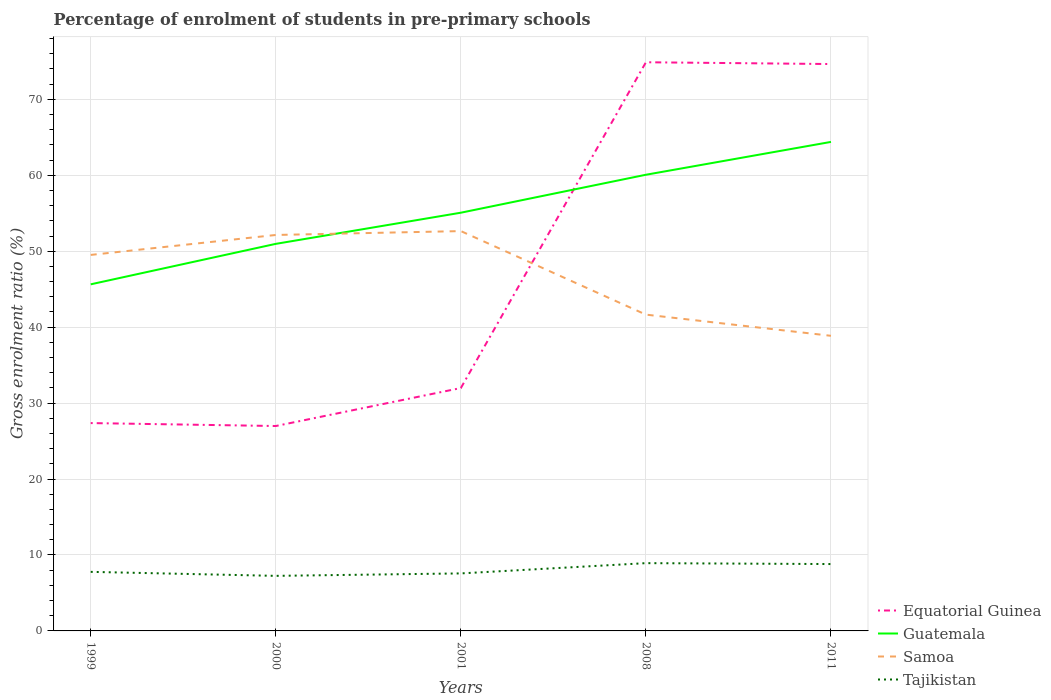How many different coloured lines are there?
Provide a short and direct response. 4. Is the number of lines equal to the number of legend labels?
Make the answer very short. Yes. Across all years, what is the maximum percentage of students enrolled in pre-primary schools in Guatemala?
Your answer should be very brief. 45.64. In which year was the percentage of students enrolled in pre-primary schools in Guatemala maximum?
Offer a very short reply. 1999. What is the total percentage of students enrolled in pre-primary schools in Guatemala in the graph?
Ensure brevity in your answer.  -4.32. What is the difference between the highest and the second highest percentage of students enrolled in pre-primary schools in Guatemala?
Give a very brief answer. 18.75. What is the difference between the highest and the lowest percentage of students enrolled in pre-primary schools in Guatemala?
Your answer should be compact. 2. How many lines are there?
Offer a very short reply. 4. How many years are there in the graph?
Your response must be concise. 5. What is the difference between two consecutive major ticks on the Y-axis?
Offer a very short reply. 10. Are the values on the major ticks of Y-axis written in scientific E-notation?
Your response must be concise. No. Where does the legend appear in the graph?
Provide a short and direct response. Bottom right. How are the legend labels stacked?
Your answer should be very brief. Vertical. What is the title of the graph?
Provide a short and direct response. Percentage of enrolment of students in pre-primary schools. Does "Thailand" appear as one of the legend labels in the graph?
Provide a succinct answer. No. What is the label or title of the Y-axis?
Your answer should be very brief. Gross enrolment ratio (%). What is the Gross enrolment ratio (%) of Equatorial Guinea in 1999?
Make the answer very short. 27.37. What is the Gross enrolment ratio (%) of Guatemala in 1999?
Your response must be concise. 45.64. What is the Gross enrolment ratio (%) of Samoa in 1999?
Your answer should be compact. 49.51. What is the Gross enrolment ratio (%) in Tajikistan in 1999?
Give a very brief answer. 7.78. What is the Gross enrolment ratio (%) in Equatorial Guinea in 2000?
Offer a very short reply. 26.98. What is the Gross enrolment ratio (%) in Guatemala in 2000?
Offer a terse response. 50.97. What is the Gross enrolment ratio (%) of Samoa in 2000?
Give a very brief answer. 52.14. What is the Gross enrolment ratio (%) in Tajikistan in 2000?
Keep it short and to the point. 7.25. What is the Gross enrolment ratio (%) in Equatorial Guinea in 2001?
Offer a very short reply. 31.98. What is the Gross enrolment ratio (%) in Guatemala in 2001?
Offer a very short reply. 55.07. What is the Gross enrolment ratio (%) of Samoa in 2001?
Your answer should be compact. 52.65. What is the Gross enrolment ratio (%) in Tajikistan in 2001?
Provide a succinct answer. 7.57. What is the Gross enrolment ratio (%) of Equatorial Guinea in 2008?
Provide a succinct answer. 74.88. What is the Gross enrolment ratio (%) of Guatemala in 2008?
Give a very brief answer. 60.07. What is the Gross enrolment ratio (%) in Samoa in 2008?
Give a very brief answer. 41.65. What is the Gross enrolment ratio (%) in Tajikistan in 2008?
Give a very brief answer. 8.92. What is the Gross enrolment ratio (%) of Equatorial Guinea in 2011?
Provide a short and direct response. 74.64. What is the Gross enrolment ratio (%) of Guatemala in 2011?
Offer a very short reply. 64.39. What is the Gross enrolment ratio (%) in Samoa in 2011?
Keep it short and to the point. 38.86. What is the Gross enrolment ratio (%) in Tajikistan in 2011?
Provide a succinct answer. 8.8. Across all years, what is the maximum Gross enrolment ratio (%) in Equatorial Guinea?
Offer a terse response. 74.88. Across all years, what is the maximum Gross enrolment ratio (%) of Guatemala?
Offer a very short reply. 64.39. Across all years, what is the maximum Gross enrolment ratio (%) in Samoa?
Keep it short and to the point. 52.65. Across all years, what is the maximum Gross enrolment ratio (%) in Tajikistan?
Your answer should be compact. 8.92. Across all years, what is the minimum Gross enrolment ratio (%) of Equatorial Guinea?
Offer a terse response. 26.98. Across all years, what is the minimum Gross enrolment ratio (%) of Guatemala?
Make the answer very short. 45.64. Across all years, what is the minimum Gross enrolment ratio (%) in Samoa?
Offer a terse response. 38.86. Across all years, what is the minimum Gross enrolment ratio (%) of Tajikistan?
Provide a succinct answer. 7.25. What is the total Gross enrolment ratio (%) of Equatorial Guinea in the graph?
Provide a short and direct response. 235.85. What is the total Gross enrolment ratio (%) of Guatemala in the graph?
Offer a terse response. 276.13. What is the total Gross enrolment ratio (%) of Samoa in the graph?
Offer a terse response. 234.8. What is the total Gross enrolment ratio (%) of Tajikistan in the graph?
Offer a terse response. 40.33. What is the difference between the Gross enrolment ratio (%) in Equatorial Guinea in 1999 and that in 2000?
Your answer should be very brief. 0.39. What is the difference between the Gross enrolment ratio (%) in Guatemala in 1999 and that in 2000?
Your answer should be very brief. -5.33. What is the difference between the Gross enrolment ratio (%) in Samoa in 1999 and that in 2000?
Keep it short and to the point. -2.63. What is the difference between the Gross enrolment ratio (%) in Tajikistan in 1999 and that in 2000?
Provide a succinct answer. 0.53. What is the difference between the Gross enrolment ratio (%) in Equatorial Guinea in 1999 and that in 2001?
Your answer should be compact. -4.61. What is the difference between the Gross enrolment ratio (%) in Guatemala in 1999 and that in 2001?
Make the answer very short. -9.43. What is the difference between the Gross enrolment ratio (%) of Samoa in 1999 and that in 2001?
Your answer should be very brief. -3.14. What is the difference between the Gross enrolment ratio (%) of Tajikistan in 1999 and that in 2001?
Ensure brevity in your answer.  0.2. What is the difference between the Gross enrolment ratio (%) in Equatorial Guinea in 1999 and that in 2008?
Make the answer very short. -47.51. What is the difference between the Gross enrolment ratio (%) in Guatemala in 1999 and that in 2008?
Provide a succinct answer. -14.43. What is the difference between the Gross enrolment ratio (%) of Samoa in 1999 and that in 2008?
Your answer should be very brief. 7.86. What is the difference between the Gross enrolment ratio (%) in Tajikistan in 1999 and that in 2008?
Make the answer very short. -1.15. What is the difference between the Gross enrolment ratio (%) of Equatorial Guinea in 1999 and that in 2011?
Keep it short and to the point. -47.27. What is the difference between the Gross enrolment ratio (%) of Guatemala in 1999 and that in 2011?
Give a very brief answer. -18.75. What is the difference between the Gross enrolment ratio (%) of Samoa in 1999 and that in 2011?
Make the answer very short. 10.65. What is the difference between the Gross enrolment ratio (%) in Tajikistan in 1999 and that in 2011?
Your answer should be very brief. -1.03. What is the difference between the Gross enrolment ratio (%) of Equatorial Guinea in 2000 and that in 2001?
Offer a terse response. -5. What is the difference between the Gross enrolment ratio (%) in Guatemala in 2000 and that in 2001?
Provide a short and direct response. -4.1. What is the difference between the Gross enrolment ratio (%) in Samoa in 2000 and that in 2001?
Offer a terse response. -0.51. What is the difference between the Gross enrolment ratio (%) in Tajikistan in 2000 and that in 2001?
Your answer should be compact. -0.32. What is the difference between the Gross enrolment ratio (%) in Equatorial Guinea in 2000 and that in 2008?
Offer a terse response. -47.9. What is the difference between the Gross enrolment ratio (%) in Guatemala in 2000 and that in 2008?
Provide a succinct answer. -9.1. What is the difference between the Gross enrolment ratio (%) of Samoa in 2000 and that in 2008?
Provide a short and direct response. 10.49. What is the difference between the Gross enrolment ratio (%) in Tajikistan in 2000 and that in 2008?
Offer a very short reply. -1.67. What is the difference between the Gross enrolment ratio (%) in Equatorial Guinea in 2000 and that in 2011?
Provide a short and direct response. -47.66. What is the difference between the Gross enrolment ratio (%) of Guatemala in 2000 and that in 2011?
Your answer should be very brief. -13.42. What is the difference between the Gross enrolment ratio (%) in Samoa in 2000 and that in 2011?
Offer a very short reply. 13.28. What is the difference between the Gross enrolment ratio (%) of Tajikistan in 2000 and that in 2011?
Provide a succinct answer. -1.55. What is the difference between the Gross enrolment ratio (%) of Equatorial Guinea in 2001 and that in 2008?
Make the answer very short. -42.9. What is the difference between the Gross enrolment ratio (%) of Guatemala in 2001 and that in 2008?
Your answer should be very brief. -5. What is the difference between the Gross enrolment ratio (%) of Samoa in 2001 and that in 2008?
Your answer should be very brief. 11. What is the difference between the Gross enrolment ratio (%) of Tajikistan in 2001 and that in 2008?
Offer a terse response. -1.35. What is the difference between the Gross enrolment ratio (%) of Equatorial Guinea in 2001 and that in 2011?
Offer a very short reply. -42.66. What is the difference between the Gross enrolment ratio (%) of Guatemala in 2001 and that in 2011?
Keep it short and to the point. -9.32. What is the difference between the Gross enrolment ratio (%) in Samoa in 2001 and that in 2011?
Your response must be concise. 13.79. What is the difference between the Gross enrolment ratio (%) of Tajikistan in 2001 and that in 2011?
Your response must be concise. -1.23. What is the difference between the Gross enrolment ratio (%) of Equatorial Guinea in 2008 and that in 2011?
Give a very brief answer. 0.24. What is the difference between the Gross enrolment ratio (%) in Guatemala in 2008 and that in 2011?
Give a very brief answer. -4.32. What is the difference between the Gross enrolment ratio (%) in Samoa in 2008 and that in 2011?
Your answer should be very brief. 2.79. What is the difference between the Gross enrolment ratio (%) of Tajikistan in 2008 and that in 2011?
Your answer should be compact. 0.12. What is the difference between the Gross enrolment ratio (%) of Equatorial Guinea in 1999 and the Gross enrolment ratio (%) of Guatemala in 2000?
Give a very brief answer. -23.6. What is the difference between the Gross enrolment ratio (%) in Equatorial Guinea in 1999 and the Gross enrolment ratio (%) in Samoa in 2000?
Offer a terse response. -24.77. What is the difference between the Gross enrolment ratio (%) of Equatorial Guinea in 1999 and the Gross enrolment ratio (%) of Tajikistan in 2000?
Your response must be concise. 20.12. What is the difference between the Gross enrolment ratio (%) in Guatemala in 1999 and the Gross enrolment ratio (%) in Samoa in 2000?
Your answer should be compact. -6.5. What is the difference between the Gross enrolment ratio (%) in Guatemala in 1999 and the Gross enrolment ratio (%) in Tajikistan in 2000?
Keep it short and to the point. 38.39. What is the difference between the Gross enrolment ratio (%) in Samoa in 1999 and the Gross enrolment ratio (%) in Tajikistan in 2000?
Provide a succinct answer. 42.26. What is the difference between the Gross enrolment ratio (%) in Equatorial Guinea in 1999 and the Gross enrolment ratio (%) in Guatemala in 2001?
Provide a short and direct response. -27.7. What is the difference between the Gross enrolment ratio (%) of Equatorial Guinea in 1999 and the Gross enrolment ratio (%) of Samoa in 2001?
Offer a terse response. -25.28. What is the difference between the Gross enrolment ratio (%) of Equatorial Guinea in 1999 and the Gross enrolment ratio (%) of Tajikistan in 2001?
Your answer should be very brief. 19.8. What is the difference between the Gross enrolment ratio (%) of Guatemala in 1999 and the Gross enrolment ratio (%) of Samoa in 2001?
Ensure brevity in your answer.  -7.01. What is the difference between the Gross enrolment ratio (%) in Guatemala in 1999 and the Gross enrolment ratio (%) in Tajikistan in 2001?
Give a very brief answer. 38.06. What is the difference between the Gross enrolment ratio (%) in Samoa in 1999 and the Gross enrolment ratio (%) in Tajikistan in 2001?
Provide a short and direct response. 41.94. What is the difference between the Gross enrolment ratio (%) of Equatorial Guinea in 1999 and the Gross enrolment ratio (%) of Guatemala in 2008?
Provide a succinct answer. -32.7. What is the difference between the Gross enrolment ratio (%) in Equatorial Guinea in 1999 and the Gross enrolment ratio (%) in Samoa in 2008?
Give a very brief answer. -14.28. What is the difference between the Gross enrolment ratio (%) in Equatorial Guinea in 1999 and the Gross enrolment ratio (%) in Tajikistan in 2008?
Give a very brief answer. 18.44. What is the difference between the Gross enrolment ratio (%) in Guatemala in 1999 and the Gross enrolment ratio (%) in Samoa in 2008?
Provide a short and direct response. 3.99. What is the difference between the Gross enrolment ratio (%) in Guatemala in 1999 and the Gross enrolment ratio (%) in Tajikistan in 2008?
Ensure brevity in your answer.  36.71. What is the difference between the Gross enrolment ratio (%) in Samoa in 1999 and the Gross enrolment ratio (%) in Tajikistan in 2008?
Make the answer very short. 40.59. What is the difference between the Gross enrolment ratio (%) in Equatorial Guinea in 1999 and the Gross enrolment ratio (%) in Guatemala in 2011?
Keep it short and to the point. -37.02. What is the difference between the Gross enrolment ratio (%) of Equatorial Guinea in 1999 and the Gross enrolment ratio (%) of Samoa in 2011?
Ensure brevity in your answer.  -11.49. What is the difference between the Gross enrolment ratio (%) in Equatorial Guinea in 1999 and the Gross enrolment ratio (%) in Tajikistan in 2011?
Make the answer very short. 18.56. What is the difference between the Gross enrolment ratio (%) of Guatemala in 1999 and the Gross enrolment ratio (%) of Samoa in 2011?
Offer a terse response. 6.78. What is the difference between the Gross enrolment ratio (%) in Guatemala in 1999 and the Gross enrolment ratio (%) in Tajikistan in 2011?
Ensure brevity in your answer.  36.83. What is the difference between the Gross enrolment ratio (%) in Samoa in 1999 and the Gross enrolment ratio (%) in Tajikistan in 2011?
Keep it short and to the point. 40.71. What is the difference between the Gross enrolment ratio (%) in Equatorial Guinea in 2000 and the Gross enrolment ratio (%) in Guatemala in 2001?
Make the answer very short. -28.09. What is the difference between the Gross enrolment ratio (%) in Equatorial Guinea in 2000 and the Gross enrolment ratio (%) in Samoa in 2001?
Your answer should be compact. -25.67. What is the difference between the Gross enrolment ratio (%) of Equatorial Guinea in 2000 and the Gross enrolment ratio (%) of Tajikistan in 2001?
Keep it short and to the point. 19.41. What is the difference between the Gross enrolment ratio (%) of Guatemala in 2000 and the Gross enrolment ratio (%) of Samoa in 2001?
Offer a very short reply. -1.68. What is the difference between the Gross enrolment ratio (%) in Guatemala in 2000 and the Gross enrolment ratio (%) in Tajikistan in 2001?
Offer a terse response. 43.39. What is the difference between the Gross enrolment ratio (%) in Samoa in 2000 and the Gross enrolment ratio (%) in Tajikistan in 2001?
Give a very brief answer. 44.56. What is the difference between the Gross enrolment ratio (%) in Equatorial Guinea in 2000 and the Gross enrolment ratio (%) in Guatemala in 2008?
Your answer should be compact. -33.09. What is the difference between the Gross enrolment ratio (%) in Equatorial Guinea in 2000 and the Gross enrolment ratio (%) in Samoa in 2008?
Offer a very short reply. -14.67. What is the difference between the Gross enrolment ratio (%) in Equatorial Guinea in 2000 and the Gross enrolment ratio (%) in Tajikistan in 2008?
Ensure brevity in your answer.  18.06. What is the difference between the Gross enrolment ratio (%) in Guatemala in 2000 and the Gross enrolment ratio (%) in Samoa in 2008?
Ensure brevity in your answer.  9.32. What is the difference between the Gross enrolment ratio (%) in Guatemala in 2000 and the Gross enrolment ratio (%) in Tajikistan in 2008?
Offer a very short reply. 42.04. What is the difference between the Gross enrolment ratio (%) of Samoa in 2000 and the Gross enrolment ratio (%) of Tajikistan in 2008?
Your answer should be very brief. 43.21. What is the difference between the Gross enrolment ratio (%) in Equatorial Guinea in 2000 and the Gross enrolment ratio (%) in Guatemala in 2011?
Offer a very short reply. -37.41. What is the difference between the Gross enrolment ratio (%) in Equatorial Guinea in 2000 and the Gross enrolment ratio (%) in Samoa in 2011?
Your answer should be compact. -11.88. What is the difference between the Gross enrolment ratio (%) in Equatorial Guinea in 2000 and the Gross enrolment ratio (%) in Tajikistan in 2011?
Give a very brief answer. 18.18. What is the difference between the Gross enrolment ratio (%) of Guatemala in 2000 and the Gross enrolment ratio (%) of Samoa in 2011?
Keep it short and to the point. 12.11. What is the difference between the Gross enrolment ratio (%) in Guatemala in 2000 and the Gross enrolment ratio (%) in Tajikistan in 2011?
Make the answer very short. 42.16. What is the difference between the Gross enrolment ratio (%) in Samoa in 2000 and the Gross enrolment ratio (%) in Tajikistan in 2011?
Keep it short and to the point. 43.33. What is the difference between the Gross enrolment ratio (%) in Equatorial Guinea in 2001 and the Gross enrolment ratio (%) in Guatemala in 2008?
Your response must be concise. -28.08. What is the difference between the Gross enrolment ratio (%) in Equatorial Guinea in 2001 and the Gross enrolment ratio (%) in Samoa in 2008?
Your response must be concise. -9.66. What is the difference between the Gross enrolment ratio (%) of Equatorial Guinea in 2001 and the Gross enrolment ratio (%) of Tajikistan in 2008?
Your answer should be compact. 23.06. What is the difference between the Gross enrolment ratio (%) in Guatemala in 2001 and the Gross enrolment ratio (%) in Samoa in 2008?
Provide a short and direct response. 13.42. What is the difference between the Gross enrolment ratio (%) in Guatemala in 2001 and the Gross enrolment ratio (%) in Tajikistan in 2008?
Make the answer very short. 46.14. What is the difference between the Gross enrolment ratio (%) of Samoa in 2001 and the Gross enrolment ratio (%) of Tajikistan in 2008?
Give a very brief answer. 43.72. What is the difference between the Gross enrolment ratio (%) of Equatorial Guinea in 2001 and the Gross enrolment ratio (%) of Guatemala in 2011?
Make the answer very short. -32.41. What is the difference between the Gross enrolment ratio (%) of Equatorial Guinea in 2001 and the Gross enrolment ratio (%) of Samoa in 2011?
Your answer should be compact. -6.88. What is the difference between the Gross enrolment ratio (%) in Equatorial Guinea in 2001 and the Gross enrolment ratio (%) in Tajikistan in 2011?
Offer a terse response. 23.18. What is the difference between the Gross enrolment ratio (%) in Guatemala in 2001 and the Gross enrolment ratio (%) in Samoa in 2011?
Offer a very short reply. 16.21. What is the difference between the Gross enrolment ratio (%) in Guatemala in 2001 and the Gross enrolment ratio (%) in Tajikistan in 2011?
Your response must be concise. 46.26. What is the difference between the Gross enrolment ratio (%) in Samoa in 2001 and the Gross enrolment ratio (%) in Tajikistan in 2011?
Provide a succinct answer. 43.84. What is the difference between the Gross enrolment ratio (%) in Equatorial Guinea in 2008 and the Gross enrolment ratio (%) in Guatemala in 2011?
Your answer should be compact. 10.49. What is the difference between the Gross enrolment ratio (%) in Equatorial Guinea in 2008 and the Gross enrolment ratio (%) in Samoa in 2011?
Make the answer very short. 36.02. What is the difference between the Gross enrolment ratio (%) in Equatorial Guinea in 2008 and the Gross enrolment ratio (%) in Tajikistan in 2011?
Provide a short and direct response. 66.07. What is the difference between the Gross enrolment ratio (%) of Guatemala in 2008 and the Gross enrolment ratio (%) of Samoa in 2011?
Your answer should be very brief. 21.21. What is the difference between the Gross enrolment ratio (%) in Guatemala in 2008 and the Gross enrolment ratio (%) in Tajikistan in 2011?
Ensure brevity in your answer.  51.26. What is the difference between the Gross enrolment ratio (%) in Samoa in 2008 and the Gross enrolment ratio (%) in Tajikistan in 2011?
Provide a short and direct response. 32.84. What is the average Gross enrolment ratio (%) in Equatorial Guinea per year?
Provide a short and direct response. 47.17. What is the average Gross enrolment ratio (%) in Guatemala per year?
Ensure brevity in your answer.  55.23. What is the average Gross enrolment ratio (%) of Samoa per year?
Provide a succinct answer. 46.96. What is the average Gross enrolment ratio (%) of Tajikistan per year?
Offer a very short reply. 8.07. In the year 1999, what is the difference between the Gross enrolment ratio (%) of Equatorial Guinea and Gross enrolment ratio (%) of Guatemala?
Provide a short and direct response. -18.27. In the year 1999, what is the difference between the Gross enrolment ratio (%) of Equatorial Guinea and Gross enrolment ratio (%) of Samoa?
Give a very brief answer. -22.14. In the year 1999, what is the difference between the Gross enrolment ratio (%) in Equatorial Guinea and Gross enrolment ratio (%) in Tajikistan?
Offer a terse response. 19.59. In the year 1999, what is the difference between the Gross enrolment ratio (%) in Guatemala and Gross enrolment ratio (%) in Samoa?
Your answer should be very brief. -3.87. In the year 1999, what is the difference between the Gross enrolment ratio (%) of Guatemala and Gross enrolment ratio (%) of Tajikistan?
Keep it short and to the point. 37.86. In the year 1999, what is the difference between the Gross enrolment ratio (%) of Samoa and Gross enrolment ratio (%) of Tajikistan?
Your response must be concise. 41.73. In the year 2000, what is the difference between the Gross enrolment ratio (%) in Equatorial Guinea and Gross enrolment ratio (%) in Guatemala?
Make the answer very short. -23.99. In the year 2000, what is the difference between the Gross enrolment ratio (%) of Equatorial Guinea and Gross enrolment ratio (%) of Samoa?
Keep it short and to the point. -25.16. In the year 2000, what is the difference between the Gross enrolment ratio (%) in Equatorial Guinea and Gross enrolment ratio (%) in Tajikistan?
Keep it short and to the point. 19.73. In the year 2000, what is the difference between the Gross enrolment ratio (%) in Guatemala and Gross enrolment ratio (%) in Samoa?
Your answer should be compact. -1.17. In the year 2000, what is the difference between the Gross enrolment ratio (%) of Guatemala and Gross enrolment ratio (%) of Tajikistan?
Provide a short and direct response. 43.72. In the year 2000, what is the difference between the Gross enrolment ratio (%) of Samoa and Gross enrolment ratio (%) of Tajikistan?
Your answer should be very brief. 44.89. In the year 2001, what is the difference between the Gross enrolment ratio (%) of Equatorial Guinea and Gross enrolment ratio (%) of Guatemala?
Your answer should be compact. -23.09. In the year 2001, what is the difference between the Gross enrolment ratio (%) of Equatorial Guinea and Gross enrolment ratio (%) of Samoa?
Your answer should be very brief. -20.67. In the year 2001, what is the difference between the Gross enrolment ratio (%) of Equatorial Guinea and Gross enrolment ratio (%) of Tajikistan?
Provide a succinct answer. 24.41. In the year 2001, what is the difference between the Gross enrolment ratio (%) in Guatemala and Gross enrolment ratio (%) in Samoa?
Offer a very short reply. 2.42. In the year 2001, what is the difference between the Gross enrolment ratio (%) of Guatemala and Gross enrolment ratio (%) of Tajikistan?
Offer a very short reply. 47.5. In the year 2001, what is the difference between the Gross enrolment ratio (%) in Samoa and Gross enrolment ratio (%) in Tajikistan?
Make the answer very short. 45.07. In the year 2008, what is the difference between the Gross enrolment ratio (%) in Equatorial Guinea and Gross enrolment ratio (%) in Guatemala?
Offer a terse response. 14.81. In the year 2008, what is the difference between the Gross enrolment ratio (%) of Equatorial Guinea and Gross enrolment ratio (%) of Samoa?
Ensure brevity in your answer.  33.23. In the year 2008, what is the difference between the Gross enrolment ratio (%) of Equatorial Guinea and Gross enrolment ratio (%) of Tajikistan?
Your answer should be very brief. 65.95. In the year 2008, what is the difference between the Gross enrolment ratio (%) in Guatemala and Gross enrolment ratio (%) in Samoa?
Ensure brevity in your answer.  18.42. In the year 2008, what is the difference between the Gross enrolment ratio (%) in Guatemala and Gross enrolment ratio (%) in Tajikistan?
Your answer should be very brief. 51.14. In the year 2008, what is the difference between the Gross enrolment ratio (%) of Samoa and Gross enrolment ratio (%) of Tajikistan?
Keep it short and to the point. 32.72. In the year 2011, what is the difference between the Gross enrolment ratio (%) in Equatorial Guinea and Gross enrolment ratio (%) in Guatemala?
Make the answer very short. 10.25. In the year 2011, what is the difference between the Gross enrolment ratio (%) of Equatorial Guinea and Gross enrolment ratio (%) of Samoa?
Your answer should be very brief. 35.78. In the year 2011, what is the difference between the Gross enrolment ratio (%) in Equatorial Guinea and Gross enrolment ratio (%) in Tajikistan?
Provide a succinct answer. 65.84. In the year 2011, what is the difference between the Gross enrolment ratio (%) in Guatemala and Gross enrolment ratio (%) in Samoa?
Your answer should be very brief. 25.53. In the year 2011, what is the difference between the Gross enrolment ratio (%) in Guatemala and Gross enrolment ratio (%) in Tajikistan?
Provide a succinct answer. 55.59. In the year 2011, what is the difference between the Gross enrolment ratio (%) of Samoa and Gross enrolment ratio (%) of Tajikistan?
Provide a short and direct response. 30.05. What is the ratio of the Gross enrolment ratio (%) in Equatorial Guinea in 1999 to that in 2000?
Provide a short and direct response. 1.01. What is the ratio of the Gross enrolment ratio (%) of Guatemala in 1999 to that in 2000?
Give a very brief answer. 0.9. What is the ratio of the Gross enrolment ratio (%) in Samoa in 1999 to that in 2000?
Your answer should be compact. 0.95. What is the ratio of the Gross enrolment ratio (%) in Tajikistan in 1999 to that in 2000?
Provide a succinct answer. 1.07. What is the ratio of the Gross enrolment ratio (%) of Equatorial Guinea in 1999 to that in 2001?
Keep it short and to the point. 0.86. What is the ratio of the Gross enrolment ratio (%) in Guatemala in 1999 to that in 2001?
Offer a very short reply. 0.83. What is the ratio of the Gross enrolment ratio (%) of Samoa in 1999 to that in 2001?
Offer a terse response. 0.94. What is the ratio of the Gross enrolment ratio (%) in Tajikistan in 1999 to that in 2001?
Offer a terse response. 1.03. What is the ratio of the Gross enrolment ratio (%) in Equatorial Guinea in 1999 to that in 2008?
Make the answer very short. 0.37. What is the ratio of the Gross enrolment ratio (%) of Guatemala in 1999 to that in 2008?
Ensure brevity in your answer.  0.76. What is the ratio of the Gross enrolment ratio (%) in Samoa in 1999 to that in 2008?
Your answer should be very brief. 1.19. What is the ratio of the Gross enrolment ratio (%) in Tajikistan in 1999 to that in 2008?
Give a very brief answer. 0.87. What is the ratio of the Gross enrolment ratio (%) in Equatorial Guinea in 1999 to that in 2011?
Ensure brevity in your answer.  0.37. What is the ratio of the Gross enrolment ratio (%) in Guatemala in 1999 to that in 2011?
Your answer should be compact. 0.71. What is the ratio of the Gross enrolment ratio (%) in Samoa in 1999 to that in 2011?
Make the answer very short. 1.27. What is the ratio of the Gross enrolment ratio (%) of Tajikistan in 1999 to that in 2011?
Keep it short and to the point. 0.88. What is the ratio of the Gross enrolment ratio (%) of Equatorial Guinea in 2000 to that in 2001?
Provide a short and direct response. 0.84. What is the ratio of the Gross enrolment ratio (%) in Guatemala in 2000 to that in 2001?
Offer a terse response. 0.93. What is the ratio of the Gross enrolment ratio (%) in Samoa in 2000 to that in 2001?
Your answer should be compact. 0.99. What is the ratio of the Gross enrolment ratio (%) of Tajikistan in 2000 to that in 2001?
Offer a very short reply. 0.96. What is the ratio of the Gross enrolment ratio (%) in Equatorial Guinea in 2000 to that in 2008?
Make the answer very short. 0.36. What is the ratio of the Gross enrolment ratio (%) of Guatemala in 2000 to that in 2008?
Give a very brief answer. 0.85. What is the ratio of the Gross enrolment ratio (%) of Samoa in 2000 to that in 2008?
Offer a terse response. 1.25. What is the ratio of the Gross enrolment ratio (%) in Tajikistan in 2000 to that in 2008?
Your answer should be compact. 0.81. What is the ratio of the Gross enrolment ratio (%) of Equatorial Guinea in 2000 to that in 2011?
Your response must be concise. 0.36. What is the ratio of the Gross enrolment ratio (%) in Guatemala in 2000 to that in 2011?
Make the answer very short. 0.79. What is the ratio of the Gross enrolment ratio (%) of Samoa in 2000 to that in 2011?
Provide a short and direct response. 1.34. What is the ratio of the Gross enrolment ratio (%) in Tajikistan in 2000 to that in 2011?
Keep it short and to the point. 0.82. What is the ratio of the Gross enrolment ratio (%) of Equatorial Guinea in 2001 to that in 2008?
Offer a terse response. 0.43. What is the ratio of the Gross enrolment ratio (%) in Guatemala in 2001 to that in 2008?
Your answer should be compact. 0.92. What is the ratio of the Gross enrolment ratio (%) of Samoa in 2001 to that in 2008?
Keep it short and to the point. 1.26. What is the ratio of the Gross enrolment ratio (%) in Tajikistan in 2001 to that in 2008?
Make the answer very short. 0.85. What is the ratio of the Gross enrolment ratio (%) of Equatorial Guinea in 2001 to that in 2011?
Your response must be concise. 0.43. What is the ratio of the Gross enrolment ratio (%) in Guatemala in 2001 to that in 2011?
Make the answer very short. 0.86. What is the ratio of the Gross enrolment ratio (%) in Samoa in 2001 to that in 2011?
Give a very brief answer. 1.35. What is the ratio of the Gross enrolment ratio (%) in Tajikistan in 2001 to that in 2011?
Offer a very short reply. 0.86. What is the ratio of the Gross enrolment ratio (%) of Guatemala in 2008 to that in 2011?
Offer a terse response. 0.93. What is the ratio of the Gross enrolment ratio (%) in Samoa in 2008 to that in 2011?
Provide a short and direct response. 1.07. What is the ratio of the Gross enrolment ratio (%) of Tajikistan in 2008 to that in 2011?
Your answer should be very brief. 1.01. What is the difference between the highest and the second highest Gross enrolment ratio (%) of Equatorial Guinea?
Offer a terse response. 0.24. What is the difference between the highest and the second highest Gross enrolment ratio (%) in Guatemala?
Your answer should be very brief. 4.32. What is the difference between the highest and the second highest Gross enrolment ratio (%) of Samoa?
Ensure brevity in your answer.  0.51. What is the difference between the highest and the second highest Gross enrolment ratio (%) of Tajikistan?
Provide a succinct answer. 0.12. What is the difference between the highest and the lowest Gross enrolment ratio (%) of Equatorial Guinea?
Provide a succinct answer. 47.9. What is the difference between the highest and the lowest Gross enrolment ratio (%) in Guatemala?
Give a very brief answer. 18.75. What is the difference between the highest and the lowest Gross enrolment ratio (%) of Samoa?
Your answer should be compact. 13.79. What is the difference between the highest and the lowest Gross enrolment ratio (%) in Tajikistan?
Offer a very short reply. 1.67. 